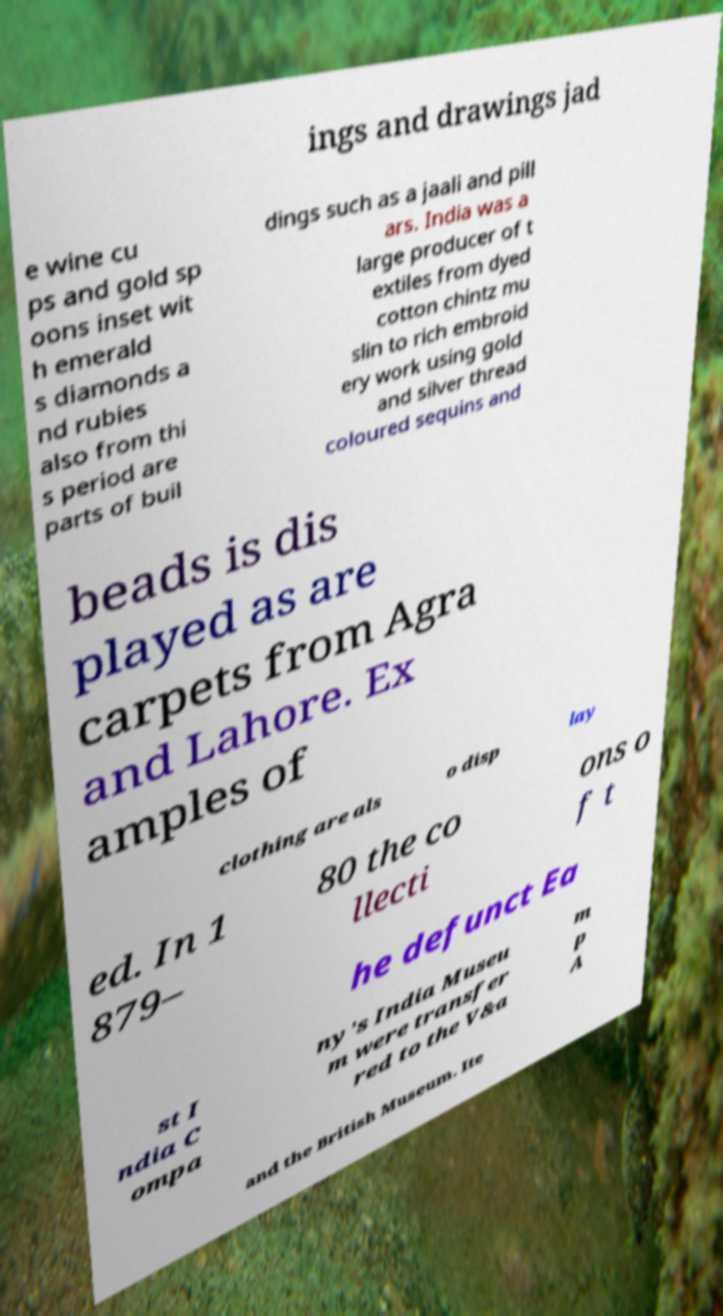There's text embedded in this image that I need extracted. Can you transcribe it verbatim? ings and drawings jad e wine cu ps and gold sp oons inset wit h emerald s diamonds a nd rubies also from thi s period are parts of buil dings such as a jaali and pill ars. India was a large producer of t extiles from dyed cotton chintz mu slin to rich embroid ery work using gold and silver thread coloured sequins and beads is dis played as are carpets from Agra and Lahore. Ex amples of clothing are als o disp lay ed. In 1 879– 80 the co llecti ons o f t he defunct Ea st I ndia C ompa ny's India Museu m were transfer red to the V&a m p A and the British Museum. Ite 